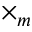<formula> <loc_0><loc_0><loc_500><loc_500>\times _ { m }</formula> 